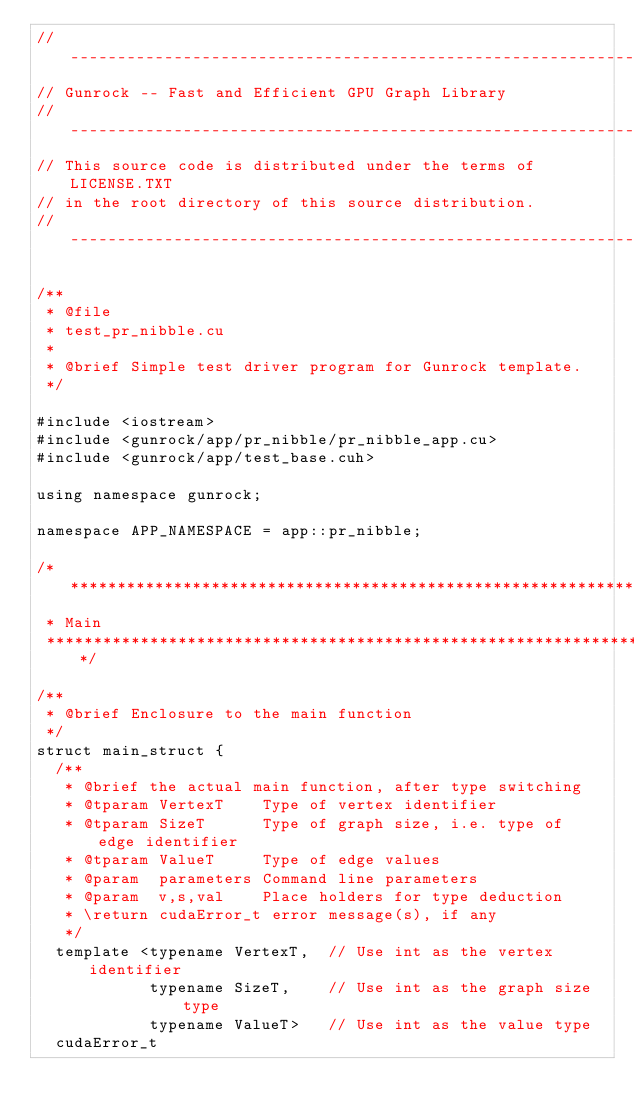Convert code to text. <code><loc_0><loc_0><loc_500><loc_500><_Cuda_>// ----------------------------------------------------------------
// Gunrock -- Fast and Efficient GPU Graph Library
// ----------------------------------------------------------------
// This source code is distributed under the terms of LICENSE.TXT
// in the root directory of this source distribution.
// ----------------------------------------------------------------

/**
 * @file
 * test_pr_nibble.cu
 *
 * @brief Simple test driver program for Gunrock template.
 */

#include <iostream>
#include <gunrock/app/pr_nibble/pr_nibble_app.cu>
#include <gunrock/app/test_base.cuh>

using namespace gunrock;

namespace APP_NAMESPACE = app::pr_nibble;

/******************************************************************************
 * Main
 ******************************************************************************/

/**
 * @brief Enclosure to the main function
 */
struct main_struct {
  /**
   * @brief the actual main function, after type switching
   * @tparam VertexT    Type of vertex identifier
   * @tparam SizeT      Type of graph size, i.e. type of edge identifier
   * @tparam ValueT     Type of edge values
   * @param  parameters Command line parameters
   * @param  v,s,val    Place holders for type deduction
   * \return cudaError_t error message(s), if any
   */
  template <typename VertexT,  // Use int as the vertex identifier
            typename SizeT,    // Use int as the graph size type
            typename ValueT>   // Use int as the value type
  cudaError_t</code> 